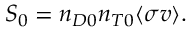<formula> <loc_0><loc_0><loc_500><loc_500>S _ { 0 } = n _ { D 0 } n _ { T 0 } \langle \sigma v \rangle .</formula> 